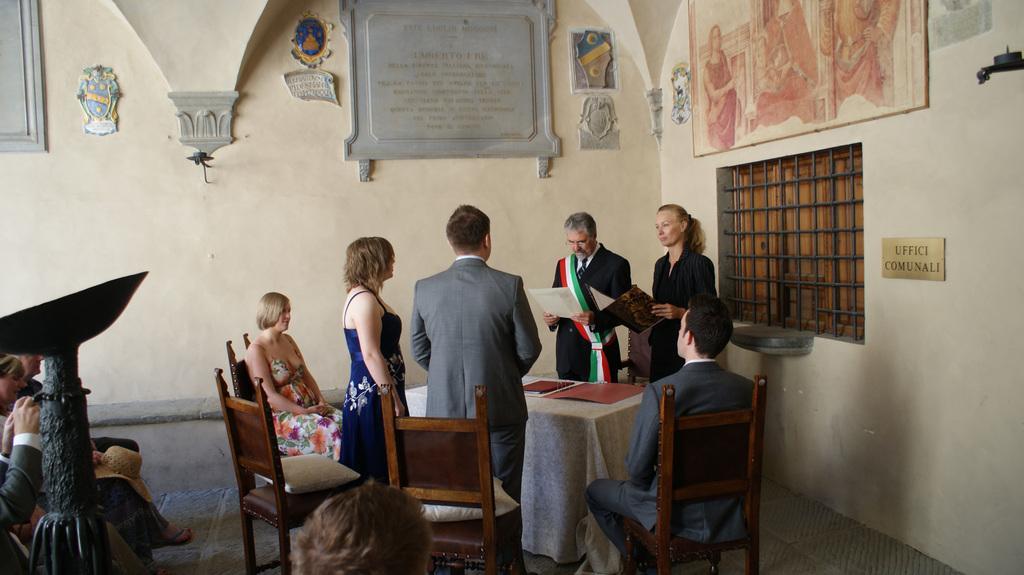In one or two sentences, can you explain what this image depicts? In this picture we have a group of people Standing and some people sitting on the chairs and some frames on the wall. 